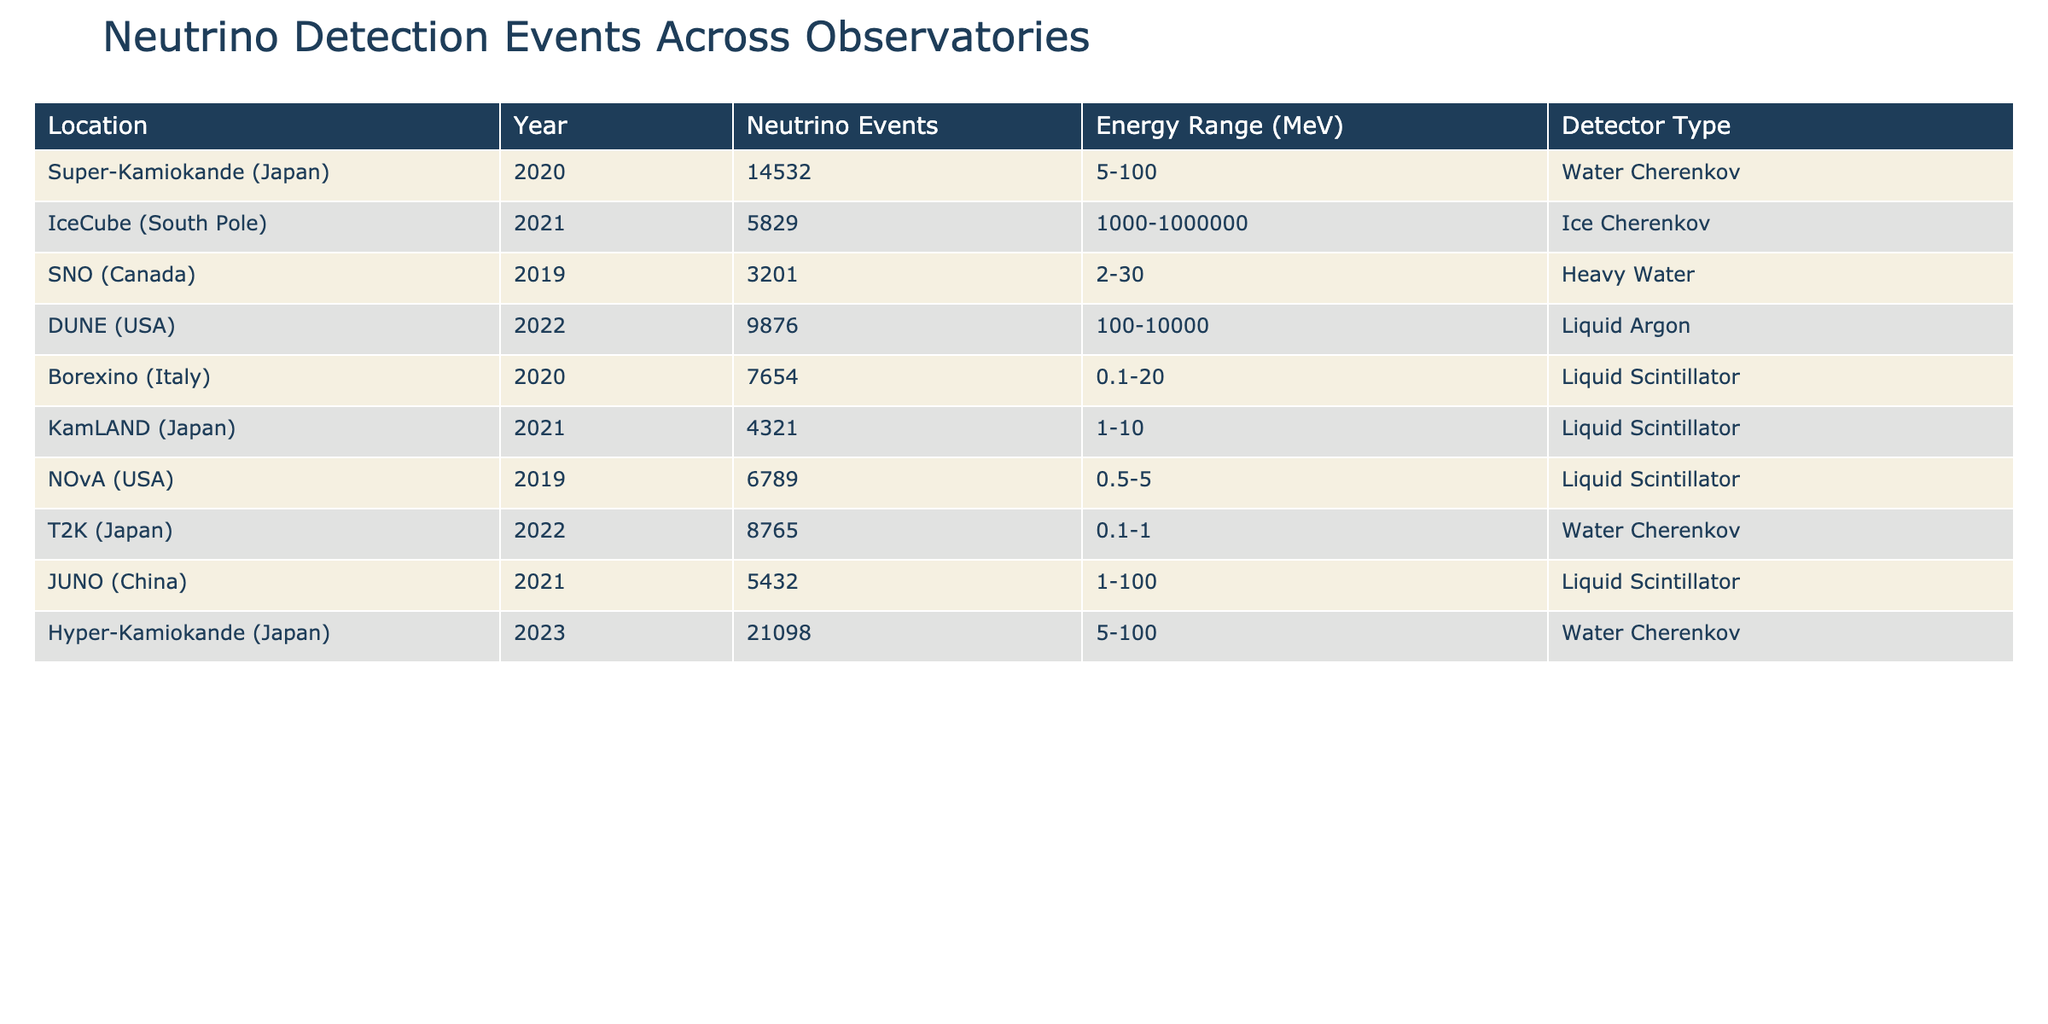What is the total number of neutrino events recorded in 2020? In 2020, the recorded neutrino events are 14532 from Super-Kamiokande and 7654 from Borexino. Adding these values gives 14532 + 7654 = 22186.
Answer: 22186 Which detector type recorded the highest number of neutrino events in the table? The table shows that Hyper-Kamiokande recorded 21098 events, which is higher than any other detectors.
Answer: Water Cherenkov What is the energy range of neutrino events detected by DUNE? DUNE's energy range for neutrino events is specified as 100-10000 MeV in the table.
Answer: 100-10000 MeV How many neutrino events were detected by IceCube in 2021? IceCube recorded 5829 neutrino events in the year 2021, as listed in the table.
Answer: 5829 What is the average number of neutrino events recorded by detectors in Japan? The detectors in Japan are Super-Kamiokande (14532), KamLAND (4321), T2K (8765), and Hyper-Kamiokande (21098). The sum is 14532 + 4321 + 8765 + 21098 = 58516. There are 4 events, so the average is 58516 / 4 = 14629.
Answer: 14629 Which observatory has the lowest number of neutrino events recorded? Looking at the table, SNO has the lowest number of events recorded at 3201, compared to the other observatories.
Answer: SNO How many more neutrino events were detected in 2022 compared to 2019? In 2022, DUNE recorded 9876 events, whereas in 2019, NOvA had 6789 and SNO had 3201, totaling 6789 + 3201 = 9990. The difference is 9876 - 9990 = -114, indicating 2022 had 114 fewer events compared to 2019 events combined.
Answer: -114 Is the energy range of the events detected by Borexino wider than that of NOvA? Borexino has an energy range of 0.1-20 MeV, and NOvA has 0.5-5 MeV. Since the upper limit of Borexino (20) is greater than that of NOvA (5), the energy range of Borexino is wider.
Answer: Yes What is the total number of neutrino events from all observatories in 2021? Adding the neutrino events from the observatories in 2021: 5829 (IceCube) + 4321 (KamLAND) + 5432 (JUNO) = 17582.
Answer: 17582 If we consider only the Liquid Scintillator detectors, what is the average number of neutrino events? The Liquid Scintillator detectors are Borexino (7654), KamLAND (4321), NOvA (6789), and JUNO (5432). Summing these gives 7654 + 4321 + 6789 + 5432 = 24196. There are 4 detectors, so the average is 24196 / 4 = 6049.
Answer: 6049 